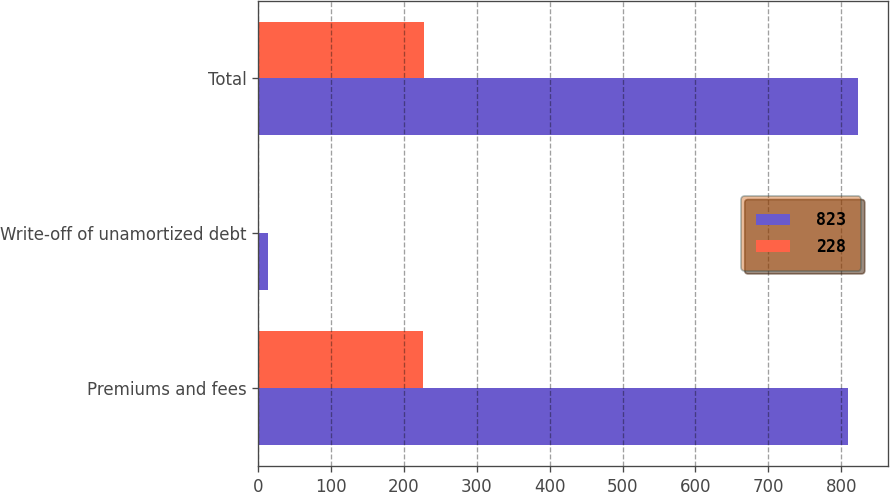Convert chart. <chart><loc_0><loc_0><loc_500><loc_500><stacked_bar_chart><ecel><fcel>Premiums and fees<fcel>Write-off of unamortized debt<fcel>Total<nl><fcel>823<fcel>809<fcel>14<fcel>823<nl><fcel>228<fcel>226<fcel>2<fcel>228<nl></chart> 